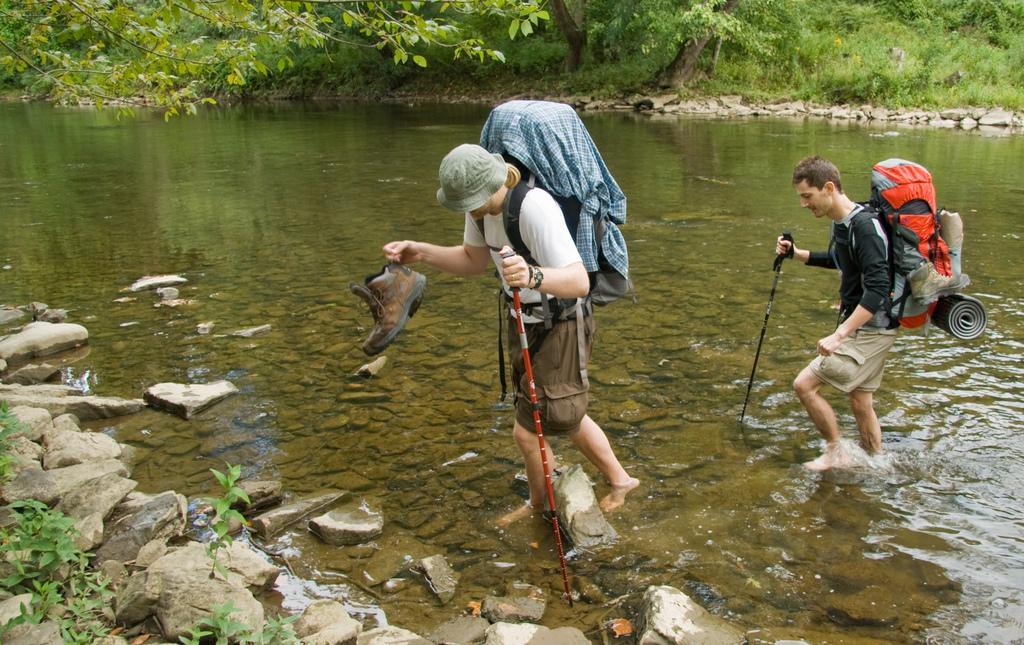Describe this image in one or two sentences. In the foreground of this image, there are two men walking in the water holding trekking sticks and wearing backpacks and a man is holding shoes in his hands. At the bottom, there are stones and plants. In the background, there are trees and the water. 